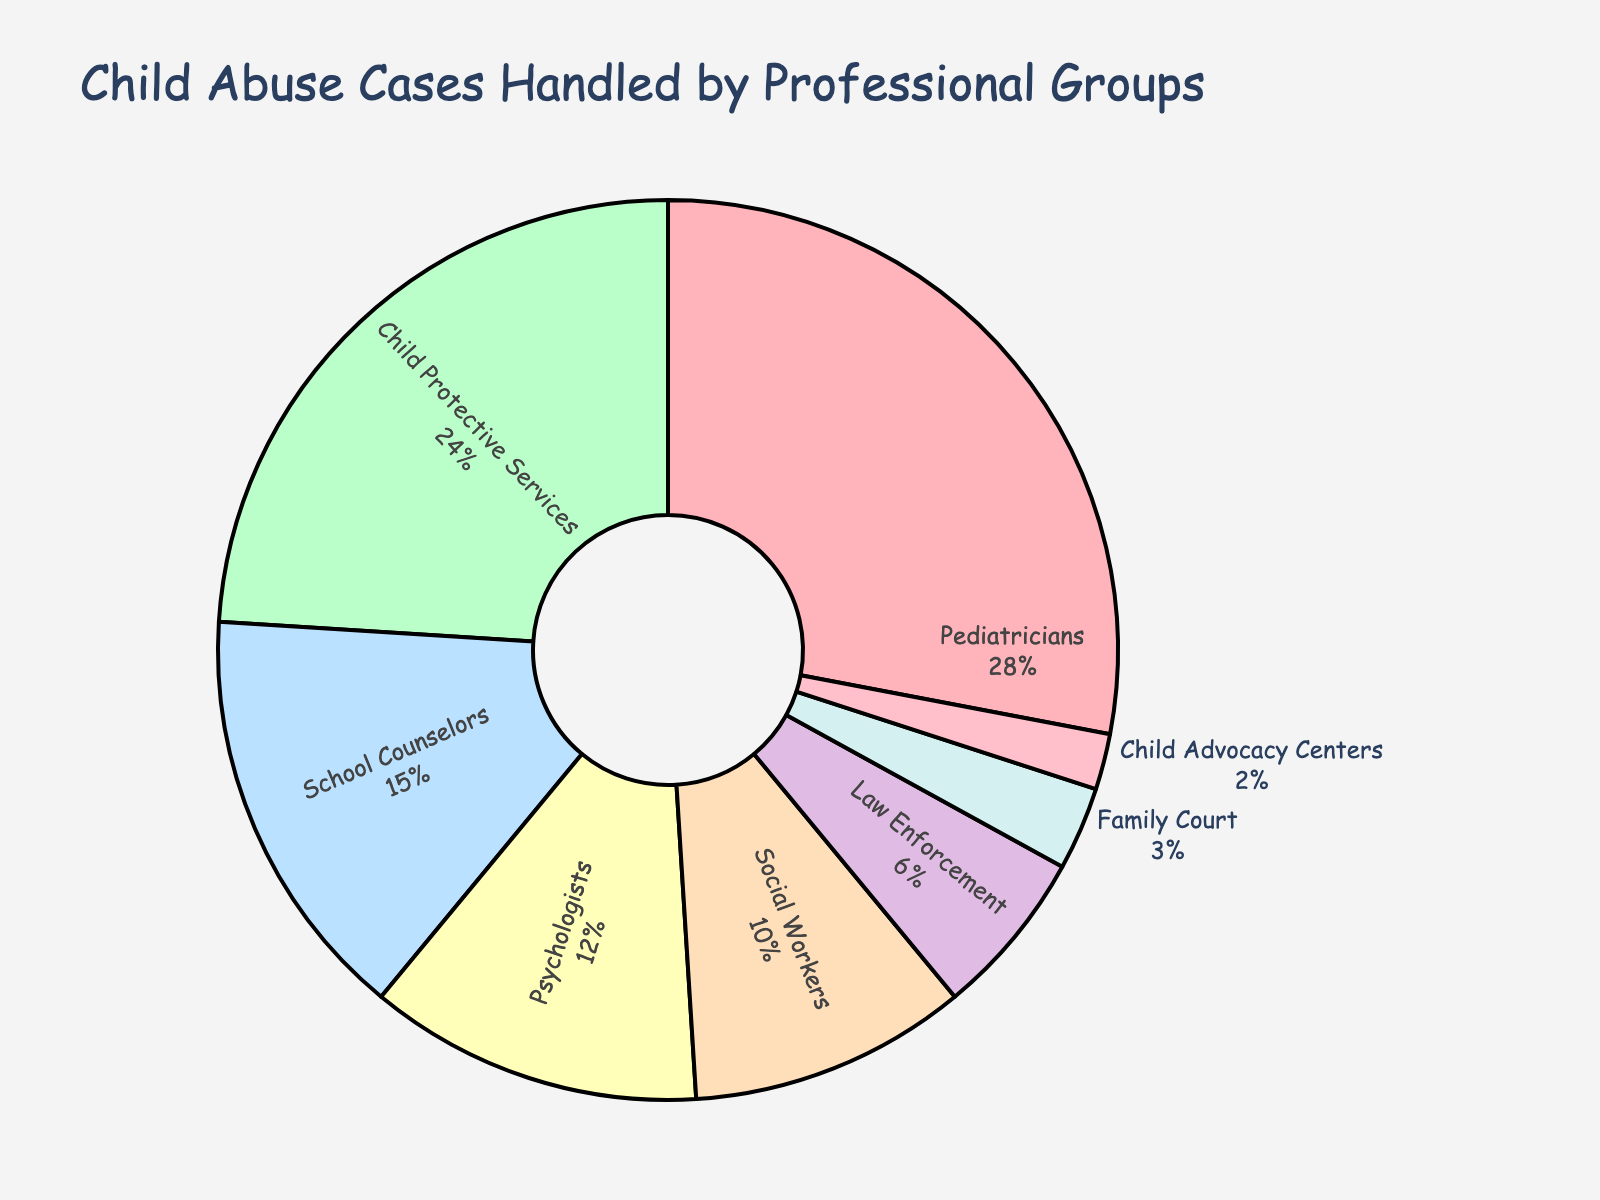Which professional group handles the majority of child abuse cases? The chart shows the percentage of cases handled by each group. The largest section of the pie chart represents the group with the majority. Pediatricians handle 28% of the cases, which is the largest percentage.
Answer: Pediatricians Which two professional groups handle the least number of cases combined? Look at the two smallest segments in the pie chart. Child Advocacy Centers handle 2% and Family Court handle 3%. Adding these, 2% + 3% = 5%.
Answer: Child Advocacy Centers and Family Court How much more percentage do Pediatricians handle compared to Psychologists? Find the percentage for both Pediatricians and Psychologists from the chart. Pediatricians handle 28% and Psychologists handle 12%. Subtract the smaller percentage from the larger: 28% - 12% = 16%.
Answer: 16% What is the total percentage handled by Child Protective Services, School Counselors, and Social Workers? Sum the percentages for these three groups: Child Protective Services (24%), School Counselors (15%), and Social Workers (10%). 24% + 15% + 10% = 49%.
Answer: 49% Which professional group is represented by the color green in the pie chart? Identify the segment colored green. According to the color scheme, Child Protective Services is shown in green.
Answer: Child Protective Services How many professional groups handle less than 10% of the cases each? Look for groups with percentages less than 10%. Social Workers (10%) do not qualify, but Law Enforcement (6%), Family Court (3%), and Child Advocacy Centers (2%) do. In total, 3 groups handle less than 10%.
Answer: 3 groups Compare the percentage handled by Social Workers to the percentage handled by Law Enforcement. From the chart, Social Workers handle 10% and Law Enforcement handle 6%. Social Workers handle more.
Answer: Social Workers handle more What percentage of cases are handled by groups other than Pediatricians? Subtract the percentage of cases handled by Pediatricians from the total, 100%: 100% - 28% = 72%.
Answer: 72% Is the combined percentage of cases handled by Pediatricians and Child Protective Services more than 50%? Pediatricians handle 28% and Child Protective Services handle 24%. Add these percentages: 28% + 24% = 52%. Since 52% is more than 50%, the answer is yes.
Answer: Yes 